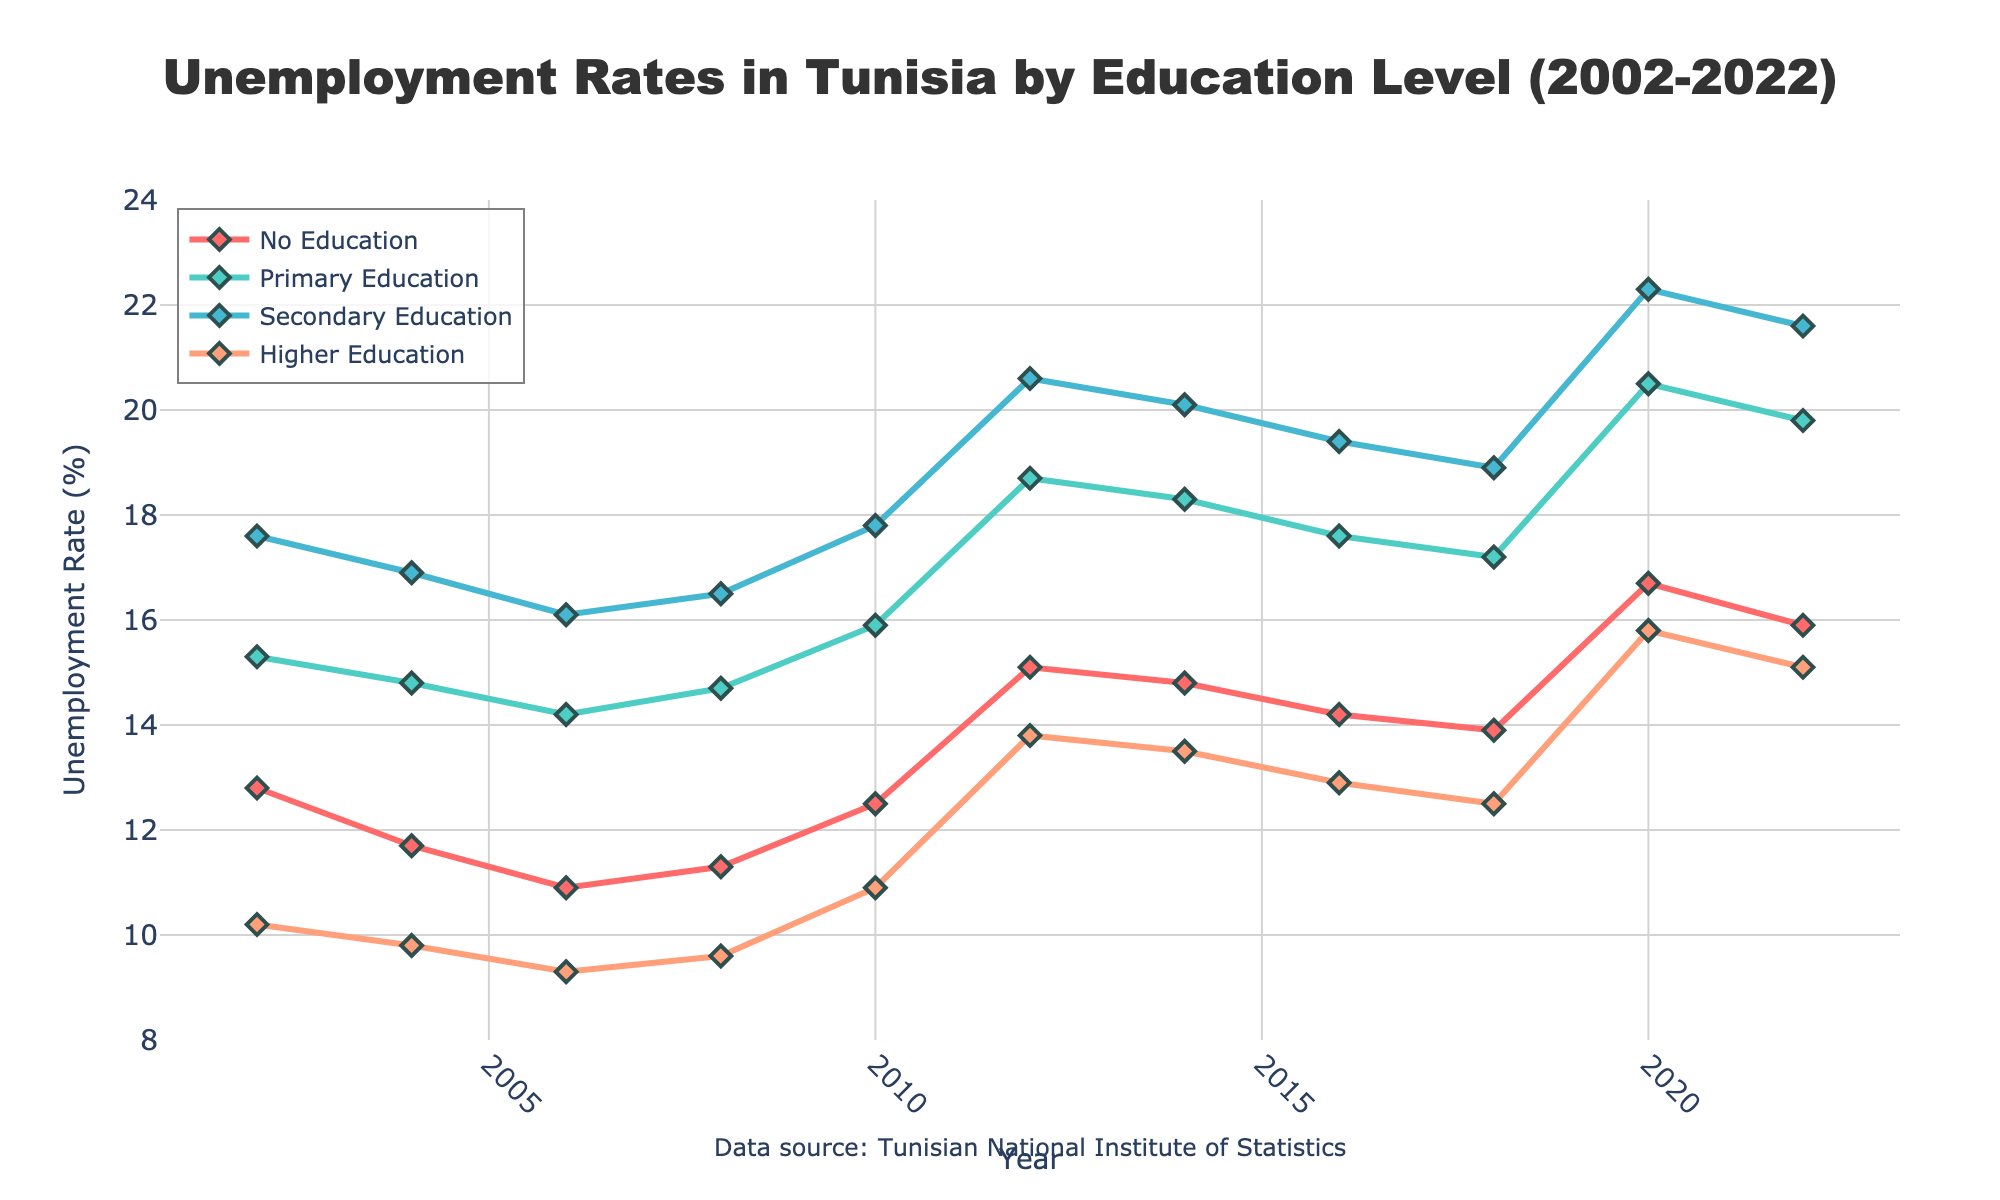Which education level had the highest unemployment rate in 2020? To find the highest unemployment rate, look at the lines in the year 2020 and check which one peaks the highest. The red line, representing "Secondary Education," is the highest.
Answer: Secondary Education How did the unemployment rate for individuals with no education change from 2002 to 2022? Compare the unemployment rate in 2002 and 2022. In 2002, it was 12.8%, and in 2022, it was 15.9%.
Answer: Increased Which education level saw the largest increase in unemployment rate from 2018 to 2020? Look at the unemployment rates for each education level in both 2018 and 2020. Then calculate the difference for each and identify the largest. "Primary Education" increased from 17.2% to 20.5%, a 3.3% rise.
Answer: Primary Education Which year experienced the highest overall unemployment rates across all education levels? Find the year where the lines collectively reach their highest points. In 2020, all education levels saw high unemployment rates, with peaks in each category.
Answer: 2020 What is the average unemployment rate for individuals with higher education over the 20 years? Sum the unemployment rates for higher education from 2002 to 2022 (10.2, 9.8, 9.3, 9.6, 10.9, 13.8, 13.5, 12.9, 12.5, 15.8, 15.1) and then divide by the number of years, which is 11. The sum is 134.4, and the average is 134.4 / 11.
Answer: 12.2 Which education level had a lower unemployment rate in 2010 compared to 2006? Compare the data points for 2006 and 2010. "No Education" had a rate of 10.9% in 2006 and 12.5% in 2010, so it didn't. "Primary Education" had 14.2% in 2006 and 15.9% in 2010, so it didn't. "Secondary Education" had 16.1% in 2006 and 17.8% in 2010, so it didn't. "Higher Education" had 9.3% in 2006 and 10.9% in 2010, so it didn't. No education levels fit the criteria.
Answer: None Which year had the smallest difference in unemployment rates between "No Education" and "Higher Education"? Calculate the differences for each year and find the smallest difference. For 2002: 12.8 - 10.2 = 2.6, 2004: 11.7 - 9.8 = 1.9, 2006: 10.9 - 9.3 = 1.6, 2008: 11.3 - 9.6 = 1.7, 2010: 12.5 - 10.9 = 1.6, etc. The smallest difference is in 2016: 14.2 - 12.9 = 1.3.
Answer: 2016 In which years did the unemployment rate for individuals with primary education exceed 18%? Identify the years when the primary education rate was above 18%. The years are 2012 (18.7%), 2014 (18.3%), 2020 (20.5%), and 2022 (19.8%).
Answer: 2012, 2014, 2020, 2022 Which education level consistently had the highest unemployment rates from 2010 to 2022? Examine the data from 2010 to 2022. The "Secondary Education" consistently has the highest unemployment rates across the period.
Answer: Secondary Education 